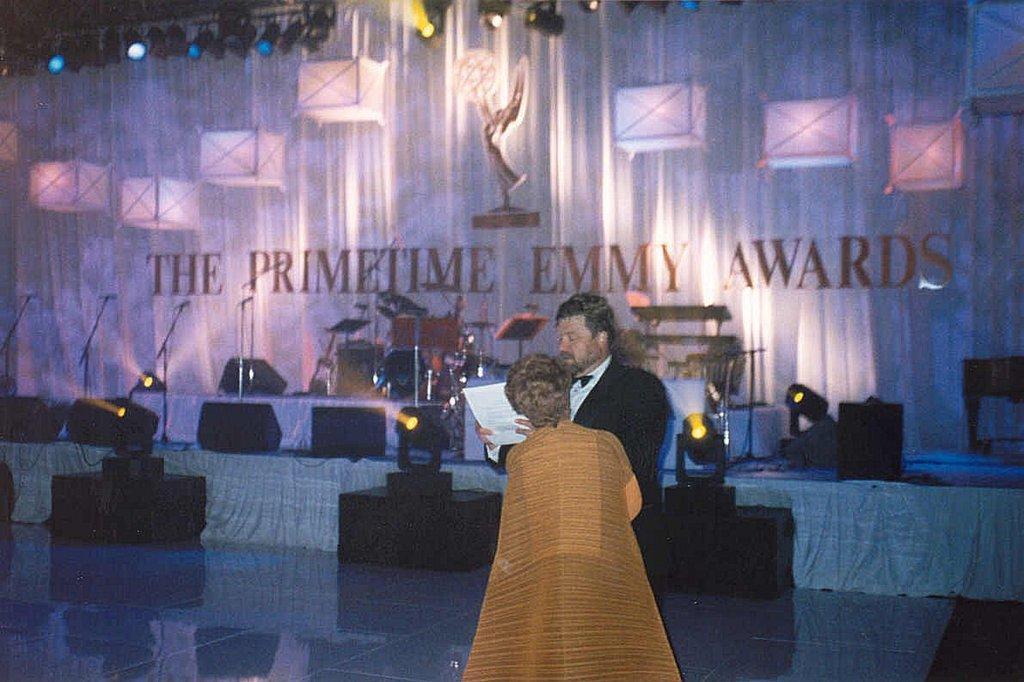In one or two sentences, can you explain what this image depicts? There is a man holding a paper and another person in the foreground area of the image, there are chairs, mics, drum set, it seems like speakers, spotlights, lamps, text on the curtain in the background. 